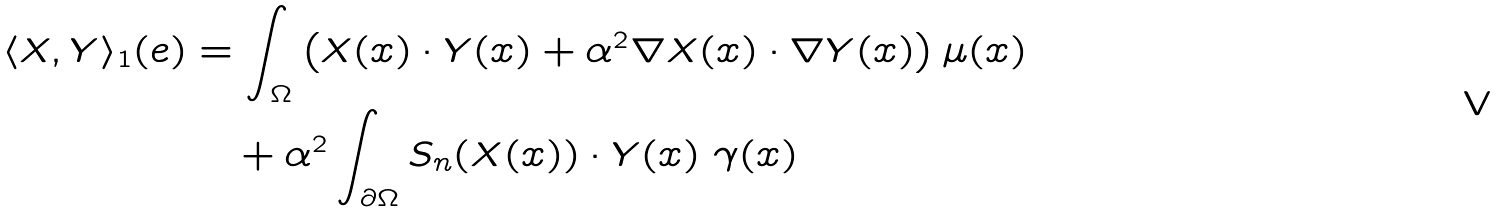<formula> <loc_0><loc_0><loc_500><loc_500>\langle X , Y \rangle _ { 1 } ( e ) & = \int _ { \Omega } \left ( X ( x ) \cdot Y ( x ) + \alpha ^ { 2 } \nabla X ( x ) \cdot \nabla Y ( x ) \right ) \mu ( x ) \\ & \quad + \alpha ^ { 2 } \int _ { \partial \Omega } S _ { n } ( X ( x ) ) \cdot Y ( x ) \ \gamma ( x )</formula> 